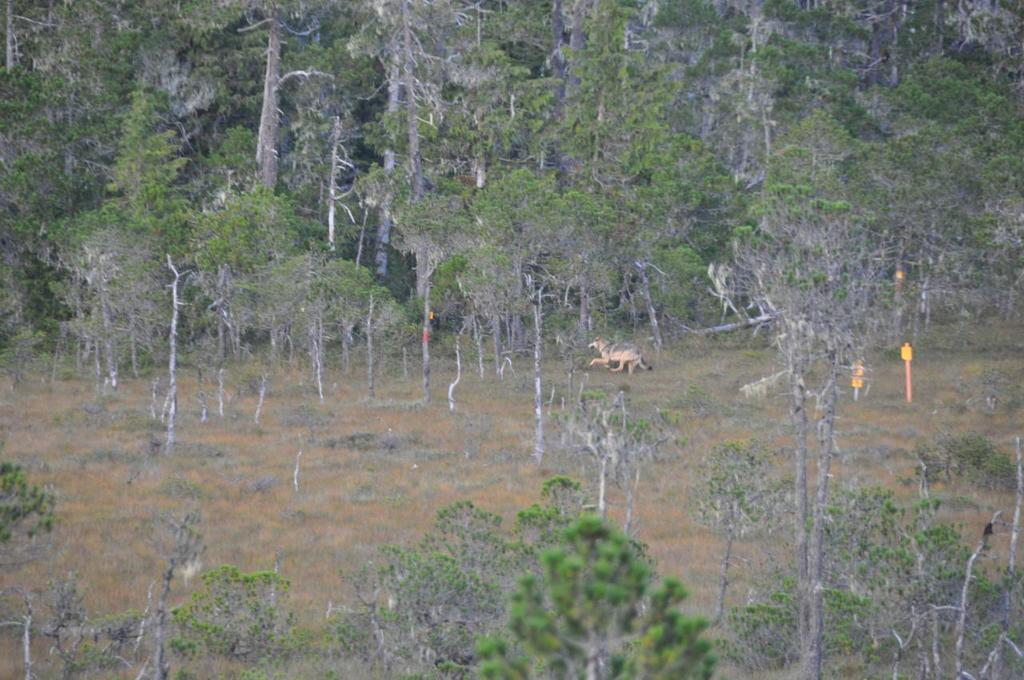What is the primary feature of the landscape in the image? The primary feature of the landscape in the image is the presence of many trees. Can you describe any living creatures in the image? Yes, there is an animal on the ground in the image. What type of flowers can be seen growing in the middle of the image? There are no flowers present in the image; it primarily features trees and an animal on the ground. 